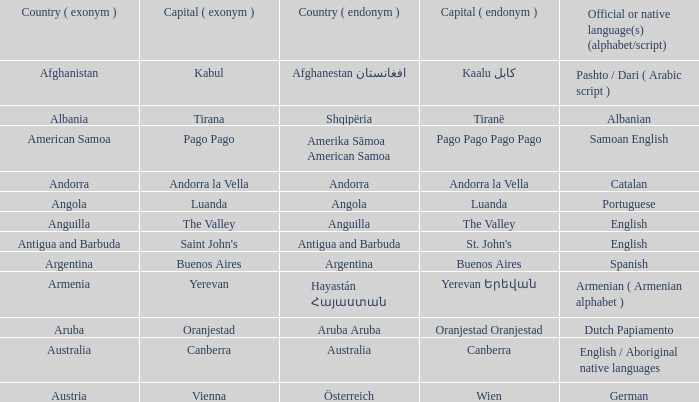In the country with canberra as its capital, what official or native languages are spoken? English / Aboriginal native languages. Help me parse the entirety of this table. {'header': ['Country ( exonym )', 'Capital ( exonym )', 'Country ( endonym )', 'Capital ( endonym )', 'Official or native language(s) (alphabet/script)'], 'rows': [['Afghanistan', 'Kabul', 'Afghanestan افغانستان', 'Kaalu كابل', 'Pashto / Dari ( Arabic script )'], ['Albania', 'Tirana', 'Shqipëria', 'Tiranë', 'Albanian'], ['American Samoa', 'Pago Pago', 'Amerika Sāmoa American Samoa', 'Pago Pago Pago Pago', 'Samoan English'], ['Andorra', 'Andorra la Vella', 'Andorra', 'Andorra la Vella', 'Catalan'], ['Angola', 'Luanda', 'Angola', 'Luanda', 'Portuguese'], ['Anguilla', 'The Valley', 'Anguilla', 'The Valley', 'English'], ['Antigua and Barbuda', "Saint John's", 'Antigua and Barbuda', "St. John's", 'English'], ['Argentina', 'Buenos Aires', 'Argentina', 'Buenos Aires', 'Spanish'], ['Armenia', 'Yerevan', 'Hayastán Հայաստան', 'Yerevan Երեվան', 'Armenian ( Armenian alphabet )'], ['Aruba', 'Oranjestad', 'Aruba Aruba', 'Oranjestad Oranjestad', 'Dutch Papiamento'], ['Australia', 'Canberra', 'Australia', 'Canberra', 'English / Aboriginal native languages'], ['Austria', 'Vienna', 'Österreich', 'Wien', 'German']]} 